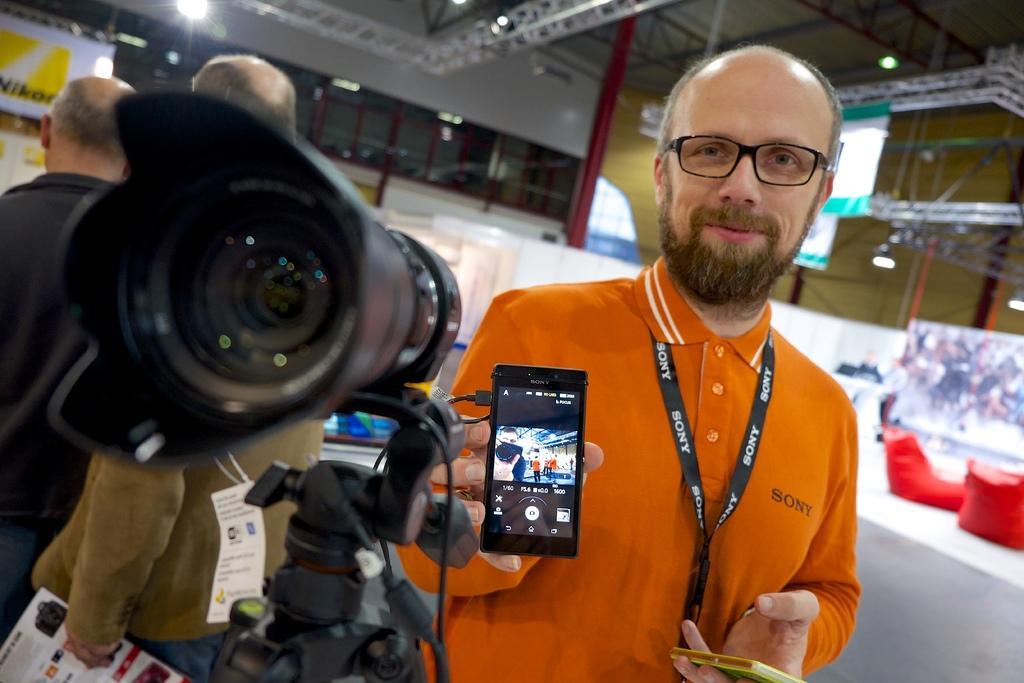Describe this image in one or two sentences. This image is clicked inside a store. In the front, there is a camera on the camera stand. There are three people in this image. To the right, the man is holding a phone and he is wearing a orange shirt. To the right, there are two red pillows. In the background, there is a wall , stand and pole. 